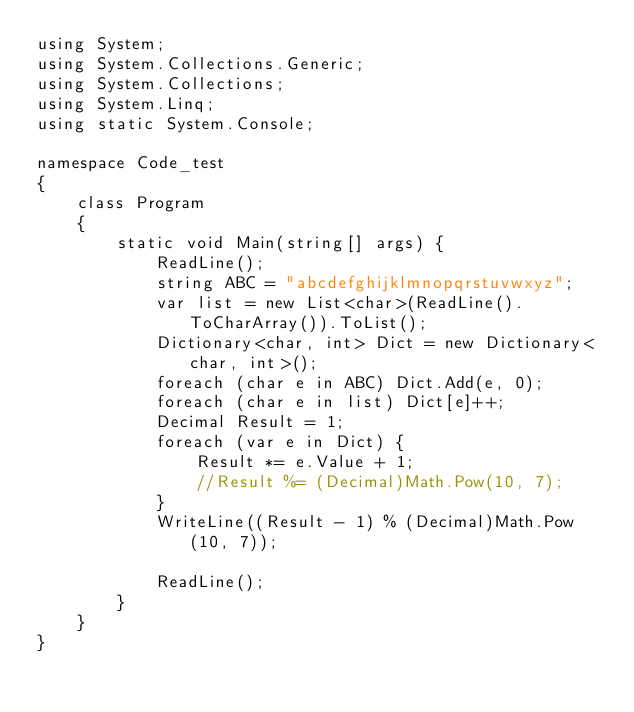Convert code to text. <code><loc_0><loc_0><loc_500><loc_500><_C#_>using System;
using System.Collections.Generic;
using System.Collections;
using System.Linq;
using static System.Console;

namespace Code_test
{
    class Program
    {
        static void Main(string[] args) {
            ReadLine();
            string ABC = "abcdefghijklmnopqrstuvwxyz";
            var list = new List<char>(ReadLine().ToCharArray()).ToList();
            Dictionary<char, int> Dict = new Dictionary<char, int>();
            foreach (char e in ABC) Dict.Add(e, 0);
            foreach (char e in list) Dict[e]++;
            Decimal Result = 1;
            foreach (var e in Dict) {
                Result *= e.Value + 1;
                //Result %= (Decimal)Math.Pow(10, 7);
            }
            WriteLine((Result - 1) % (Decimal)Math.Pow(10, 7));

            ReadLine();
        }
    }
}</code> 